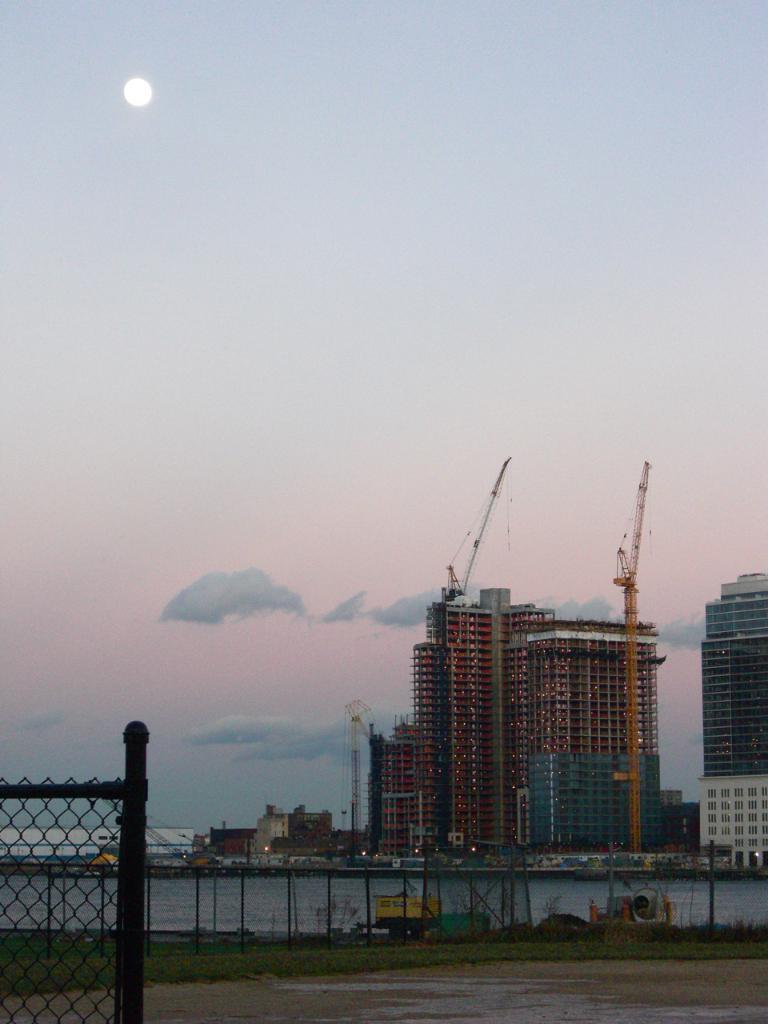Could you give a brief overview of what you see in this image? In the center of the image, we can see buildings, towers and some lights. In the background, there is a fence and we can see meshes, traffic cones, vehicles and there is water and ground. At the top, there is sun in the sky. 